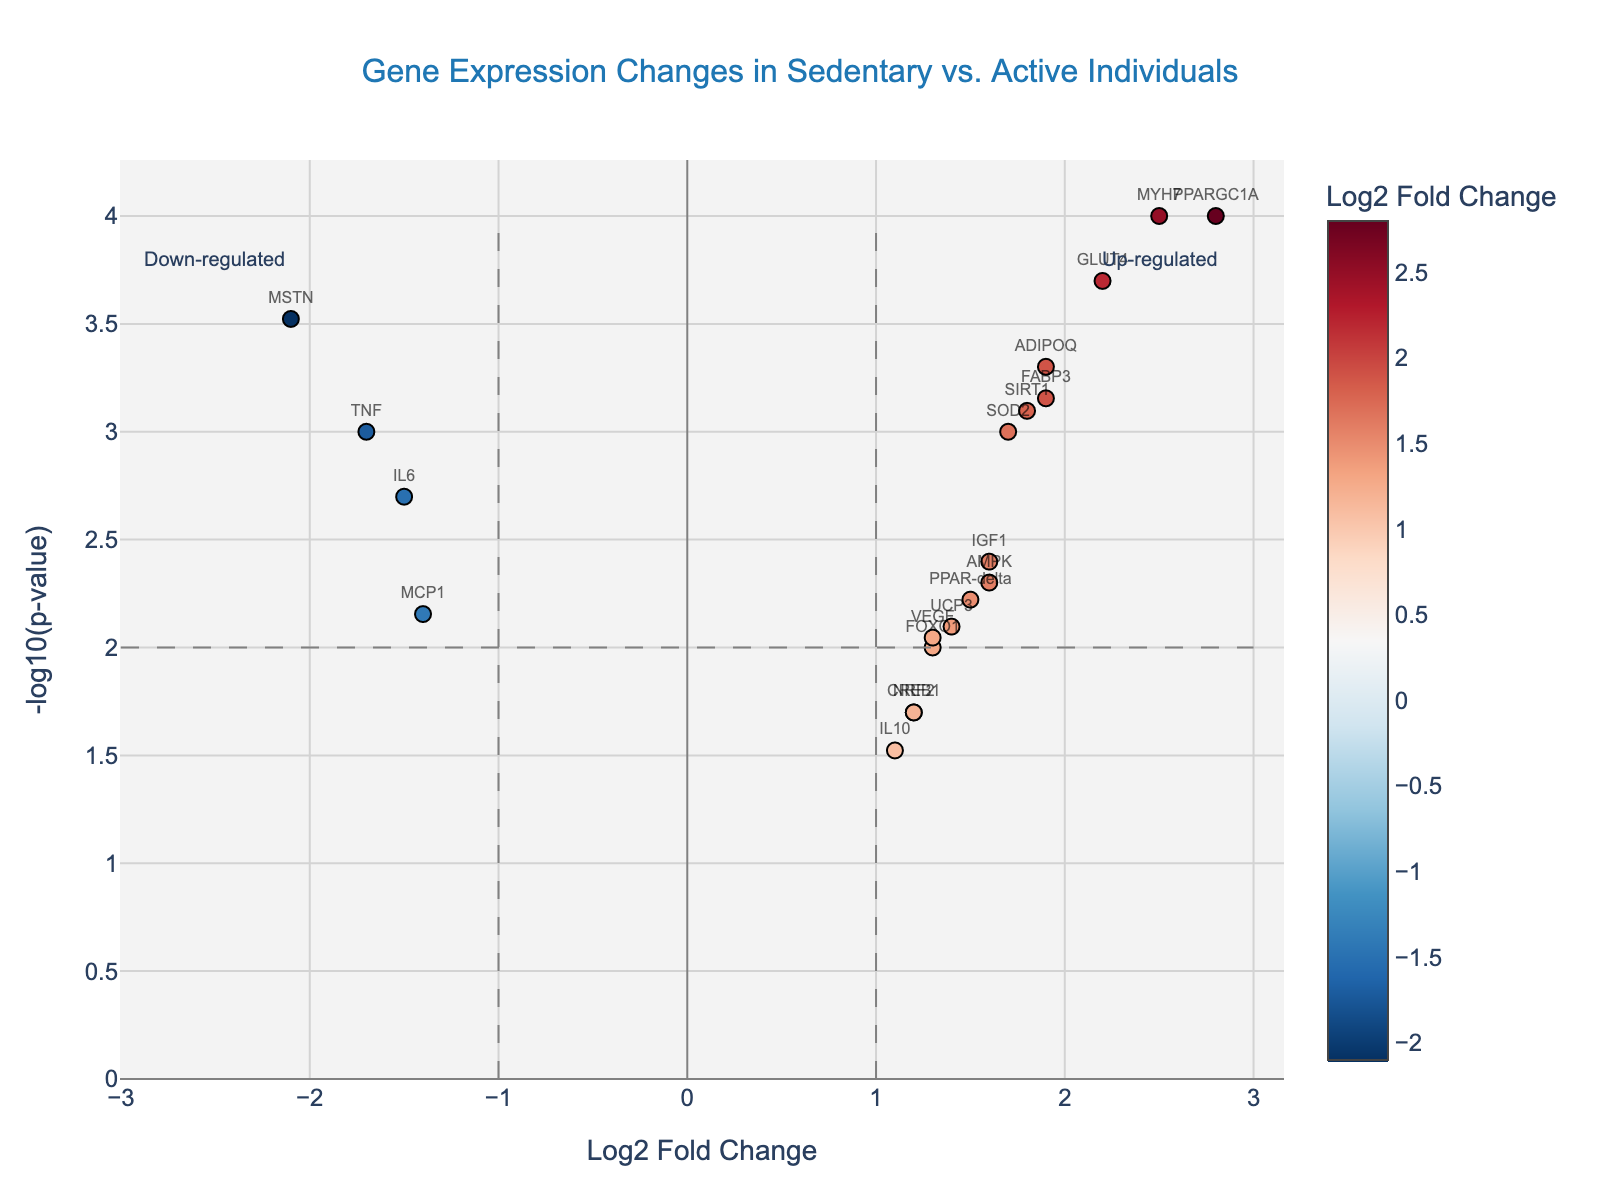What is the title of the figure? The title can be found at the top center of the figure. It reads "Gene Expression Changes in Sedentary vs. Active Individuals".
Answer: Gene Expression Changes in Sedentary vs. Active Individuals What do the x and y axes represent? The x-axis title indicates it's the "Log2 Fold Change", which measures the ratio of gene expression between active and sedentary individuals. The y-axis title is "-log10(p-value)", representing the statistical significance of the differences in gene expression.
Answer: Log2 Fold Change and -log10(p-value) Which gene has the highest log2 fold change? Look at the x-axis to see which gene has the highest value. The gene on the far right with the highest x-axis value is PPARGC1A.
Answer: PPARGC1A What is the significance threshold indicated by the horizontal line? The horizontal line marks the -log10(p-value) threshold for significance. The value at which this line is drawn is 2, translating to a p-value of 0.01.
Answer: 0.01 Which gene has the highest statistical significance? Find the gene with the highest y-axis value, which represents the lowest p-value (-log10(p-value)). The gene at the top of the y-axis is PPARGC1A.
Answer: PPARGC1A How many genes are up-regulated (log2 fold change > 1) and significant (p-value < 0.01)? Look for genes with x-axis values > 1 and y-axis values > 2. The genes are PPARGC1A, ADIPOQ, GLUT4, MYH7, and SIRT1. There are 5 such genes.
Answer: 5 Which genes are strongly down-regulated (log2 fold change < -1) and significant (p-value < 0.01)? Find genes with x-axis values < -1 and y-axis values > 2. The genes meeting these criteria are IL6, TNF, and MSTN.
Answer: IL6, TNF, MSTN What is the log2 fold change for the gene UCP3? Locate the gene UCP3 on the plot based on its label. The corresponding x-axis value (log2 fold change) for UCP3 is 1.4.
Answer: 1.4 How many genes are both up-regulated (log2 fold change > 0) and significant (p-value < 0.01)? Count genes with positive x-axis values and y-axis values greater than 2. The genes are PPARGC1A, ADIPOQ, GLUT4, MYH7, SIRT1, and FABP3. There are 6 such genes.
Answer: 6 Is FOXO1 more or less significant than VEGF in terms of p-value? Compare the y-axis (-log10(p-value)) values for FOXO1 and VEGF. VEGF's y-axis value is higher than FOXO1's, indicating VEGF is more significant (lower p-value) than FOXO1.
Answer: More significant 